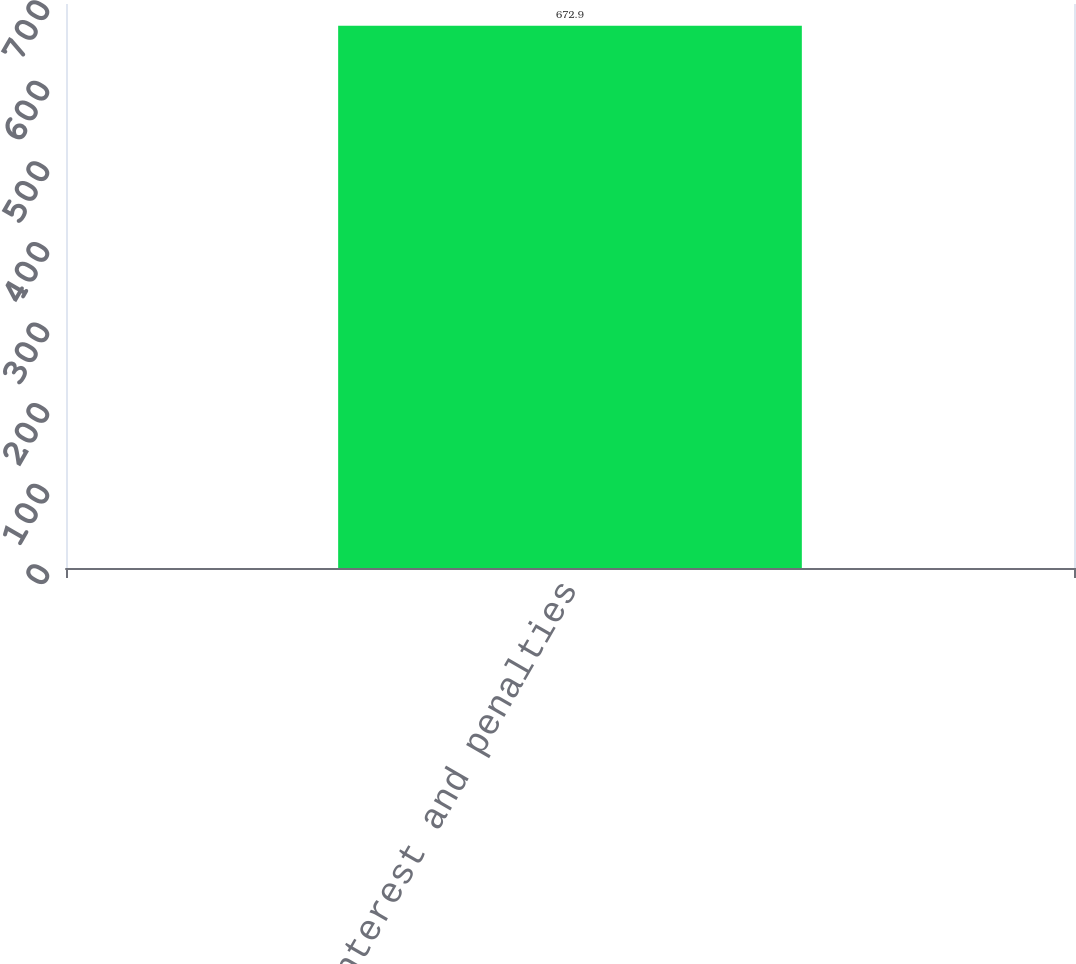<chart> <loc_0><loc_0><loc_500><loc_500><bar_chart><fcel>Total interest and penalties<nl><fcel>672.9<nl></chart> 